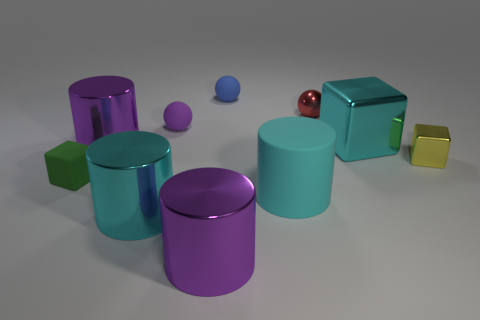How many tiny things are cyan metal cylinders or blocks?
Your response must be concise. 2. There is a cyan cylinder that is to the left of the purple cylinder in front of the purple cylinder that is behind the small matte cube; what size is it?
Your response must be concise. Large. Are there any other things of the same color as the big matte cylinder?
Your answer should be very brief. Yes. What is the material of the purple cylinder that is behind the tiny matte cube that is in front of the cylinder behind the cyan block?
Provide a succinct answer. Metal. Does the tiny blue thing have the same shape as the large rubber thing?
Keep it short and to the point. No. Are there any other things that have the same material as the small purple sphere?
Your response must be concise. Yes. How many spheres are in front of the tiny blue matte thing and behind the tiny purple matte object?
Provide a short and direct response. 1. There is a small cube that is to the right of the big cyan shiny object that is on the right side of the small purple rubber object; what is its color?
Your answer should be very brief. Yellow. Is the number of large shiny things in front of the tiny green matte object the same as the number of tiny balls?
Ensure brevity in your answer.  No. There is a tiny block left of the large purple cylinder behind the green object; what number of small purple objects are right of it?
Your answer should be compact. 1. 